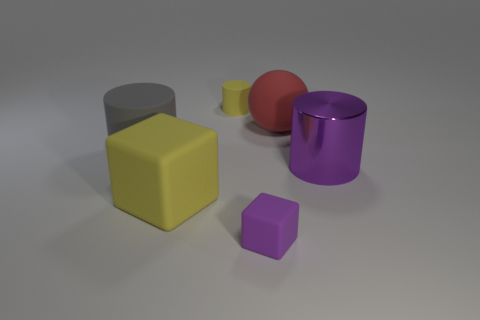Add 1 small gray matte cylinders. How many objects exist? 7 Subtract all balls. How many objects are left? 5 Add 5 red matte spheres. How many red matte spheres are left? 6 Add 5 yellow objects. How many yellow objects exist? 7 Subtract 0 cyan balls. How many objects are left? 6 Subtract all yellow blocks. Subtract all small green matte objects. How many objects are left? 5 